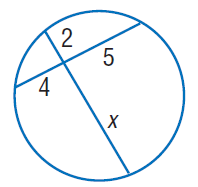Question: Find x. Round to the nearest tenth if necessary. Assume that segments that appear to be tangent are tangent.
Choices:
A. 2
B. 4
C. 5
D. 10
Answer with the letter. Answer: D 